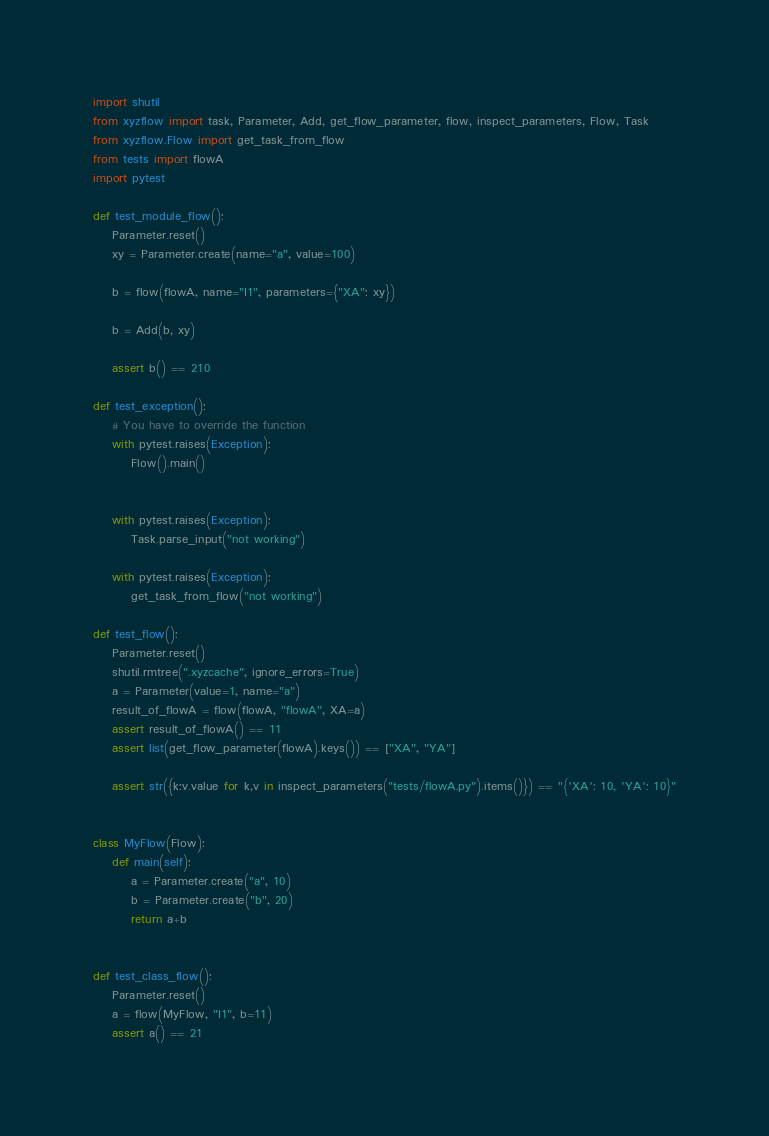Convert code to text. <code><loc_0><loc_0><loc_500><loc_500><_Python_>import shutil
from xyzflow import task, Parameter, Add, get_flow_parameter, flow, inspect_parameters, Flow, Task
from xyzflow.Flow import get_task_from_flow
from tests import flowA
import pytest

def test_module_flow():
    Parameter.reset()
    xy = Parameter.create(name="a", value=100)

    b = flow(flowA, name="I1", parameters={"XA": xy})

    b = Add(b, xy)

    assert b() == 210
    
def test_exception():
    # You have to override the function
    with pytest.raises(Exception):
        Flow().main()
        
    
    with pytest.raises(Exception):
        Task.parse_input("not working")
        
    with pytest.raises(Exception):
        get_task_from_flow("not working")

def test_flow():
    Parameter.reset()
    shutil.rmtree(".xyzcache", ignore_errors=True)
    a = Parameter(value=1, name="a")
    result_of_flowA = flow(flowA, "flowA", XA=a)
    assert result_of_flowA() == 11
    assert list(get_flow_parameter(flowA).keys()) == ["XA", "YA"]
    
    assert str({k:v.value for k,v in inspect_parameters("tests/flowA.py").items()}) == "{'XA': 10, 'YA': 10}"
        
        
class MyFlow(Flow):
    def main(self):
        a = Parameter.create("a", 10)
        b = Parameter.create("b", 20)
        return a+b
    
    
def test_class_flow():
    Parameter.reset()
    a = flow(MyFlow, "I1", b=11)
    assert a() == 21</code> 